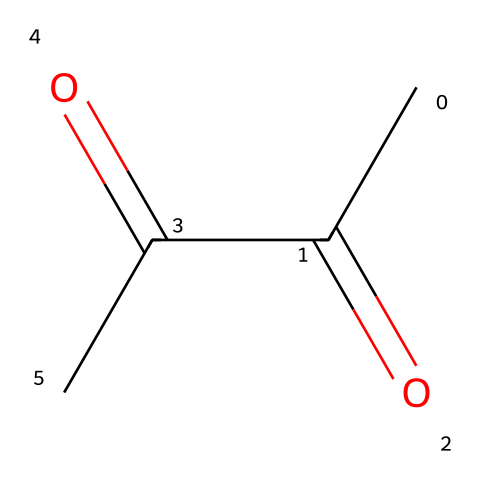What is the name of this compound? The SMILES representation "CC(=O)C(=O)C" corresponds to a chemical with four carbon atoms, two ketone functional groups (indicated by the "=O" next to carbon atoms), and fits the nomenclature of 2,3-butanedione.
Answer: 2,3-butanedione How many carbon atoms are in this molecule? By analyzing the SMILES string "CC(=O)C(=O)C," we can count the number of 'C' letters. There are four carbon atoms present in total.
Answer: 4 What type of functional groups are present in this molecule? The presence of "C(=O)" in the SMILES indicates two carbonyl groups, which classify the compound as a ketone due to the carbonyl groups being located between carbon atoms.
Answer: ketones How many oxygen atoms are there in this chemical structure? In the given SMILES, there are two occurrences of the "=O" indicating carbonyl groups, hence there are two oxygen atoms located in the structure.
Answer: 2 Is this compound a saturated or unsaturated ketone? Despite the presence of double bonds with oxygen, the rest of the carbon framework is fully saturated with respect to the hydrogen count, which indicates it does not have any double bonds between carbon atoms, classifying it as saturated.
Answer: saturated What is the molecular formula of this compound? Taking into account the four carbon atoms (C4), two oxygen atoms (O2), and six hydrogen atoms that saturate the remaining valency, the molecular formula derived from the structure is C4H6O2.
Answer: C4H6O2 